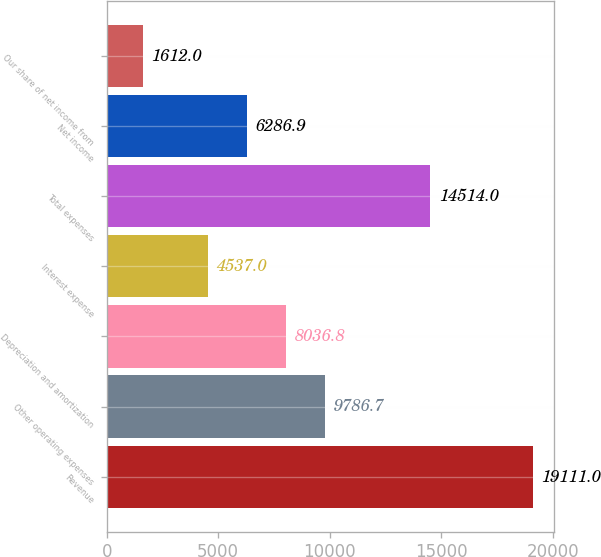<chart> <loc_0><loc_0><loc_500><loc_500><bar_chart><fcel>Revenue<fcel>Other operating expenses<fcel>Depreciation and amortization<fcel>Interest expense<fcel>Total expenses<fcel>Net income<fcel>Our share of net income from<nl><fcel>19111<fcel>9786.7<fcel>8036.8<fcel>4537<fcel>14514<fcel>6286.9<fcel>1612<nl></chart> 